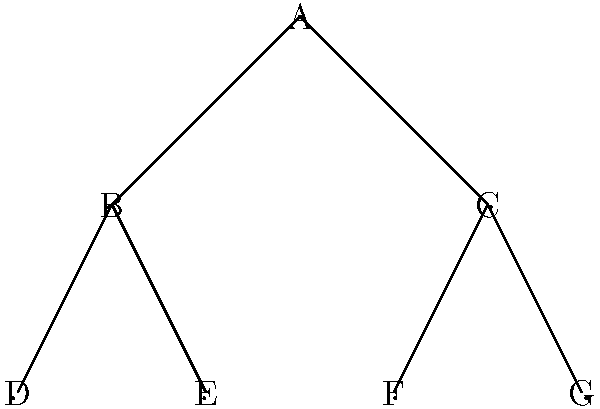In the family tree diagram representing relationships within your tribe, how many generations are depicted, and what is the maximum number of children any individual has in this representation? To answer this question, we need to analyze the structure of the family tree:

1. Identify the root:
   - Node A is at the top, representing the oldest generation.

2. Count the generations:
   - Level 1: Node A
   - Level 2: Nodes B and C
   - Level 3: Nodes D, E, F, and G
   - There are 3 generations in total.

3. Determine the maximum number of children:
   - Node A has 2 children (B and C)
   - Node B has 2 children (D and E)
   - Node C has 2 children (F and G)
   - The maximum number of children for any individual is 2.

Therefore, the family tree depicts 3 generations, and the maximum number of children any individual has is 2.
Answer: 3 generations; 2 children 